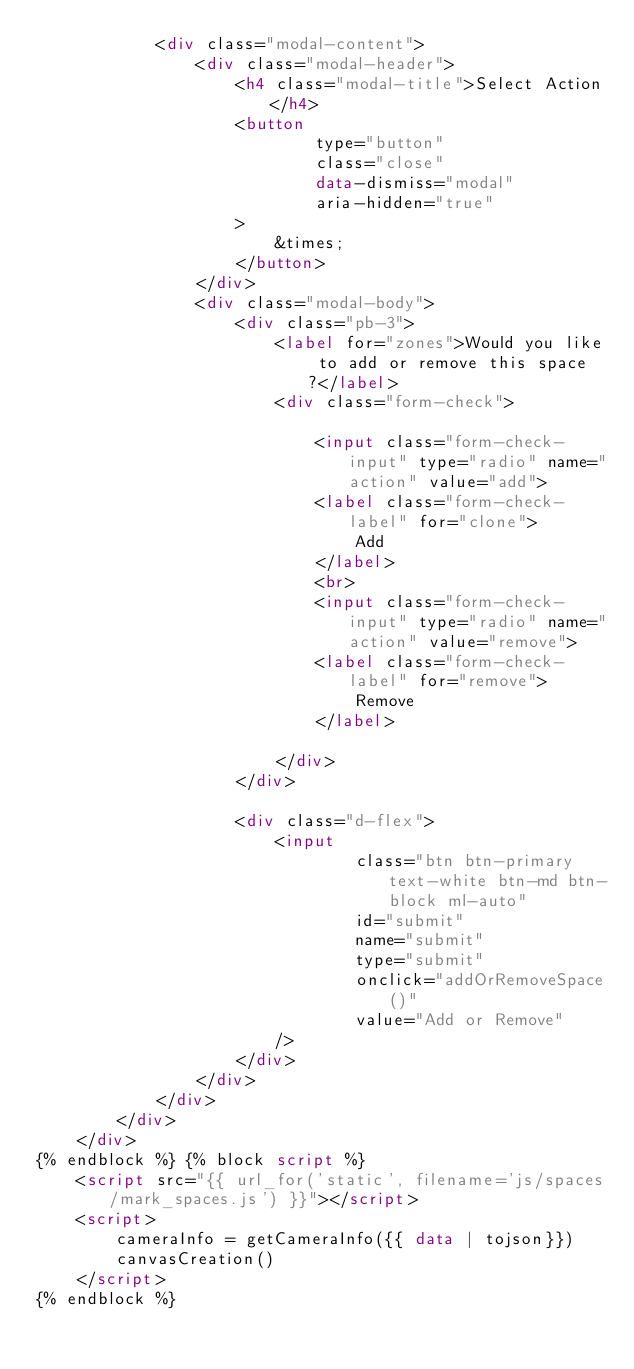<code> <loc_0><loc_0><loc_500><loc_500><_HTML_>            <div class="modal-content">
                <div class="modal-header">
                    <h4 class="modal-title">Select Action</h4>
                    <button
                            type="button"
                            class="close"
                            data-dismiss="modal"
                            aria-hidden="true"
                    >
                        &times;
                    </button>
                </div>
                <div class="modal-body">
                    <div class="pb-3">
                        <label for="zones">Would you like to add or remove this space?</label>
                        <div class="form-check">

                            <input class="form-check-input" type="radio" name="action" value="add">
                            <label class="form-check-label" for="clone">
                                Add
                            </label>
                            <br>
                            <input class="form-check-input" type="radio" name="action" value="remove">
                            <label class="form-check-label" for="remove">
                                Remove
                            </label>

                        </div>
                    </div>

                    <div class="d-flex">
                        <input
                                class="btn btn-primary text-white btn-md btn-block ml-auto"
                                id="submit"
                                name="submit"
                                type="submit"
                                onclick="addOrRemoveSpace()"
                                value="Add or Remove"
                        />
                    </div>
                </div>
            </div>
        </div>
    </div>
{% endblock %} {% block script %}
    <script src="{{ url_for('static', filename='js/spaces/mark_spaces.js') }}"></script>
    <script>
        cameraInfo = getCameraInfo({{ data | tojson}})
        canvasCreation()
    </script>
{% endblock %}
</code> 